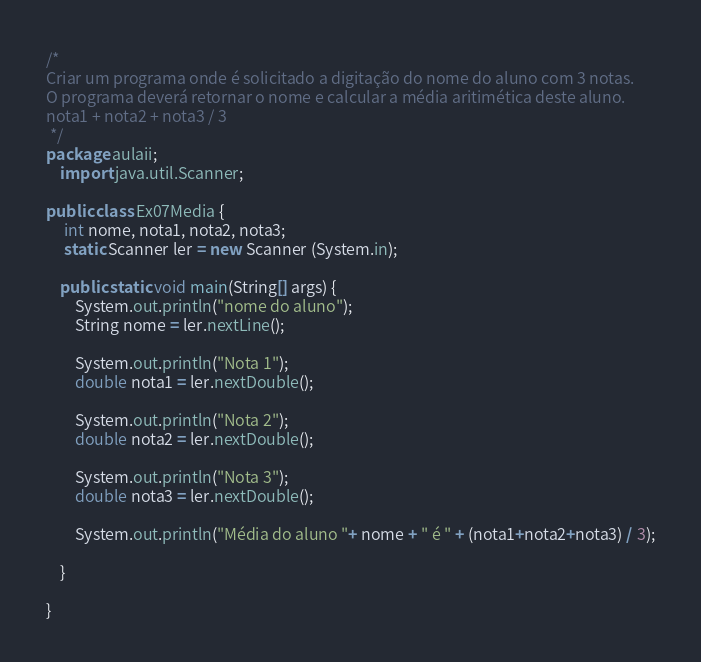Convert code to text. <code><loc_0><loc_0><loc_500><loc_500><_Java_>/*
Criar um programa onde é solicitado a digitação do nome do aluno com 3 notas.
O programa deverá retornar o nome e calcular a média aritimética deste aluno.
nota1 + nota2 + nota3 / 3
 */
package aulaii;
    import java.util.Scanner;

public class Ex07Media {
     int nome, nota1, nota2, nota3;
     static Scanner ler = new Scanner (System.in);
    
    public static void main(String[] args) {
        System.out.println("nome do aluno");
        String nome = ler.nextLine();
        
        System.out.println("Nota 1");
        double nota1 = ler.nextDouble();
        
        System.out.println("Nota 2");
        double nota2 = ler.nextDouble();
        
        System.out.println("Nota 3");
        double nota3 = ler.nextDouble();
        
        System.out.println("Média do aluno "+ nome + " é " + (nota1+nota2+nota3) / 3);
        
    }
    
}
</code> 